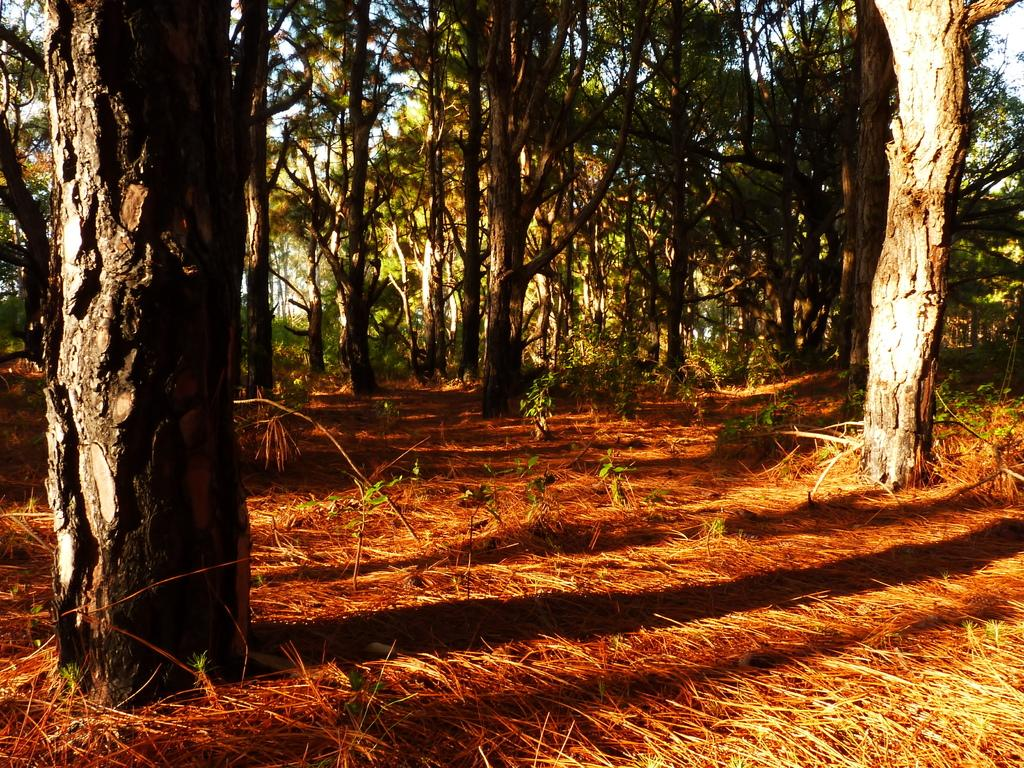What type of vegetation is visible in the image? There is grass, plants, and trees visible in the image. Can you describe the natural environment depicted in the image? The image features a variety of vegetation, including grass, plants, and trees. What type of cable can be seen connecting the trees in the image? There is no cable present in the image; it features only grass, plants, and trees. 